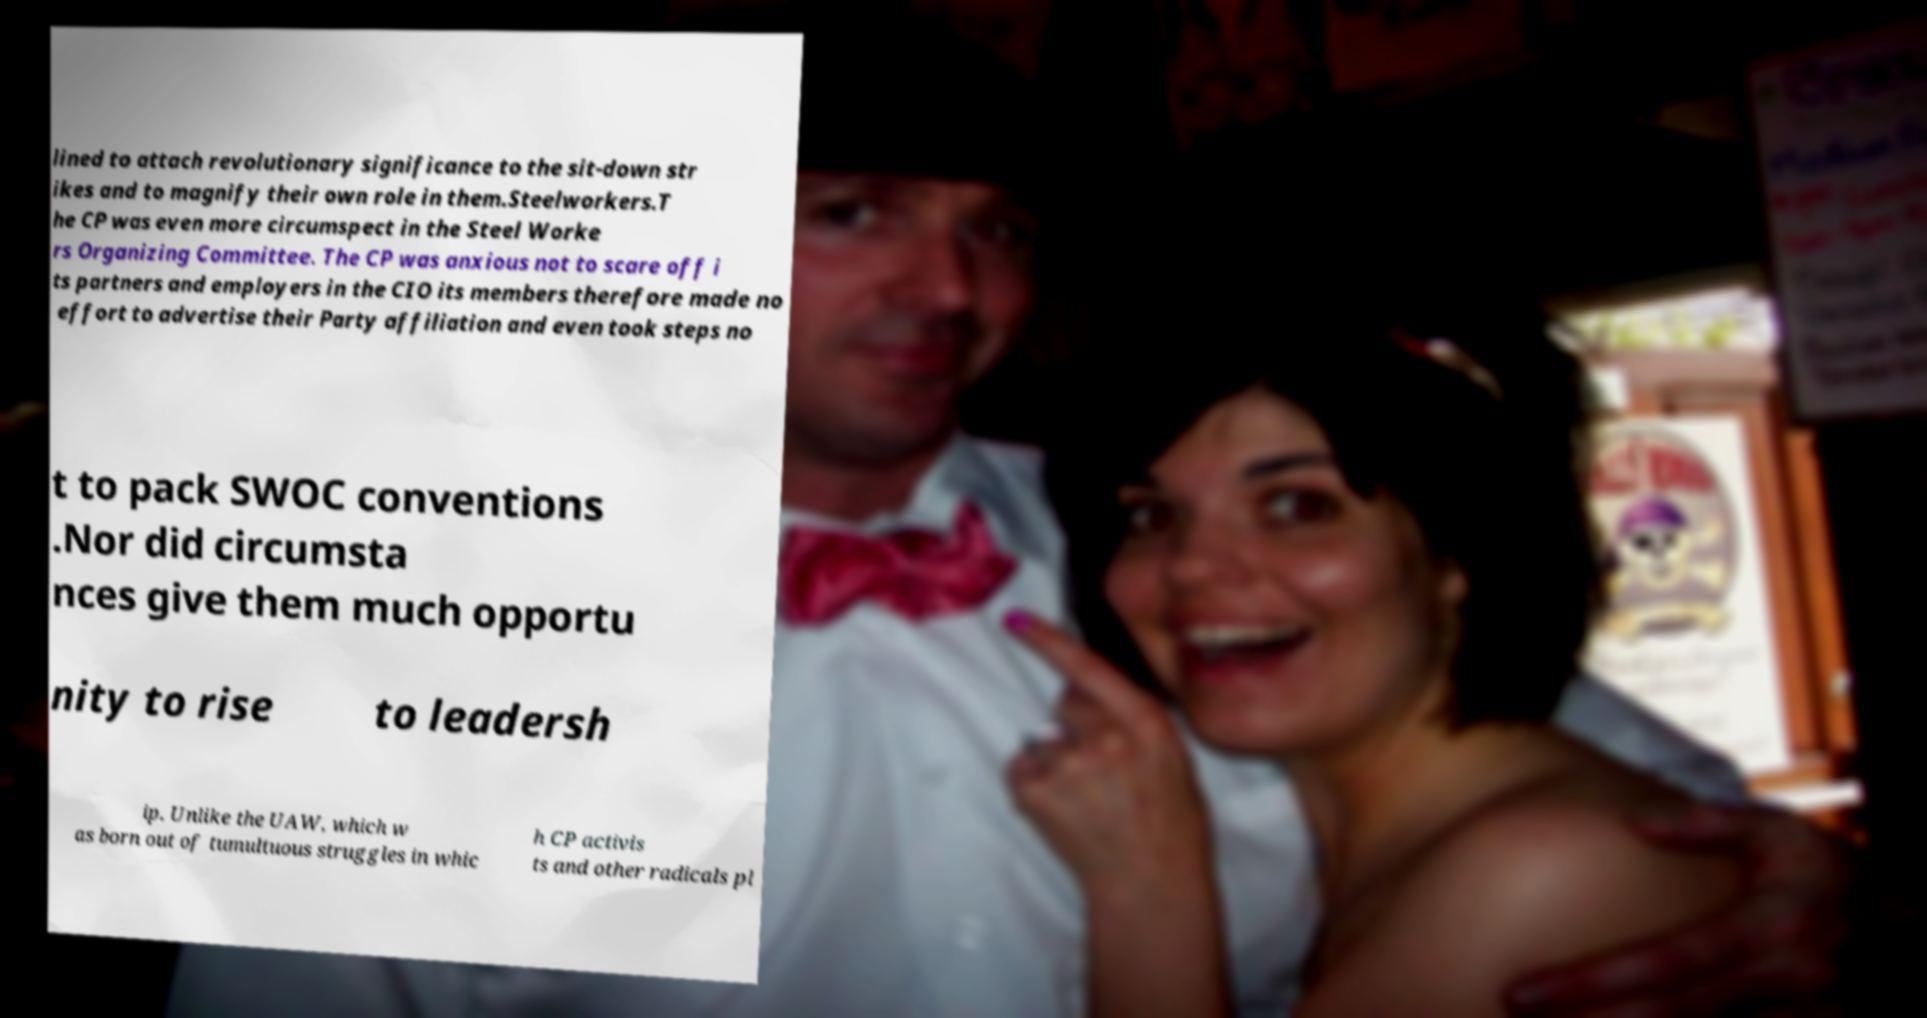Can you read and provide the text displayed in the image?This photo seems to have some interesting text. Can you extract and type it out for me? lined to attach revolutionary significance to the sit-down str ikes and to magnify their own role in them.Steelworkers.T he CP was even more circumspect in the Steel Worke rs Organizing Committee. The CP was anxious not to scare off i ts partners and employers in the CIO its members therefore made no effort to advertise their Party affiliation and even took steps no t to pack SWOC conventions .Nor did circumsta nces give them much opportu nity to rise to leadersh ip. Unlike the UAW, which w as born out of tumultuous struggles in whic h CP activis ts and other radicals pl 